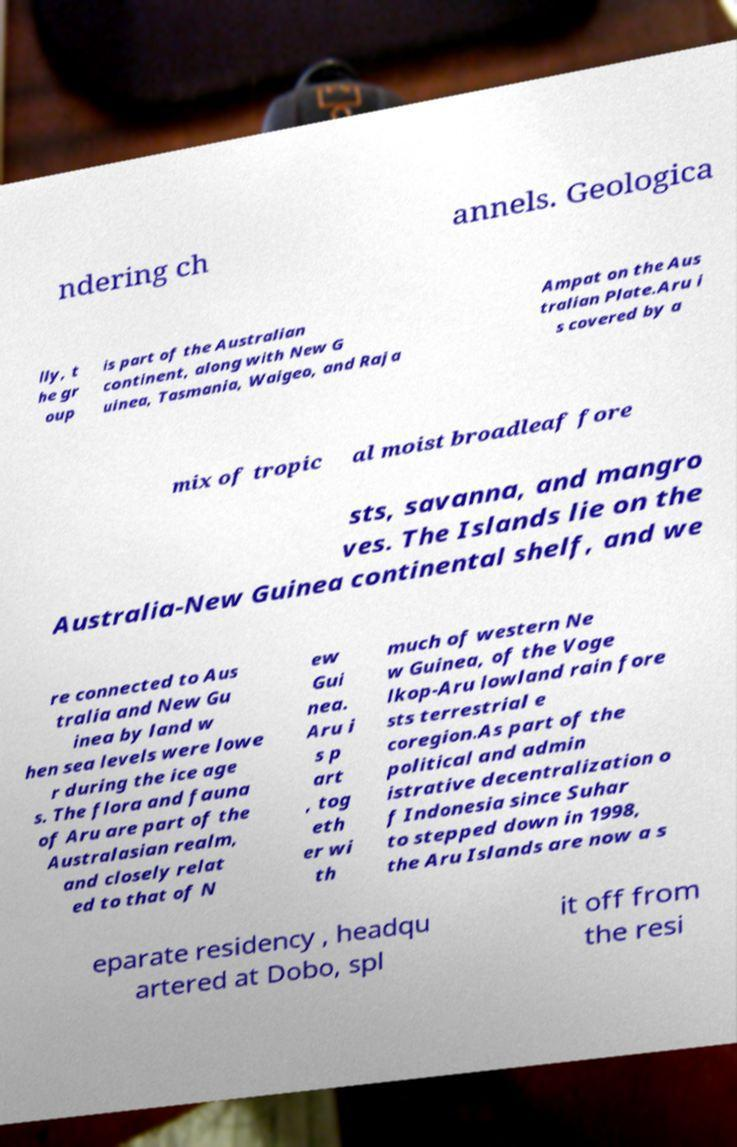I need the written content from this picture converted into text. Can you do that? ndering ch annels. Geologica lly, t he gr oup is part of the Australian continent, along with New G uinea, Tasmania, Waigeo, and Raja Ampat on the Aus tralian Plate.Aru i s covered by a mix of tropic al moist broadleaf fore sts, savanna, and mangro ves. The Islands lie on the Australia-New Guinea continental shelf, and we re connected to Aus tralia and New Gu inea by land w hen sea levels were lowe r during the ice age s. The flora and fauna of Aru are part of the Australasian realm, and closely relat ed to that of N ew Gui nea. Aru i s p art , tog eth er wi th much of western Ne w Guinea, of the Voge lkop-Aru lowland rain fore sts terrestrial e coregion.As part of the political and admin istrative decentralization o f Indonesia since Suhar to stepped down in 1998, the Aru Islands are now a s eparate residency , headqu artered at Dobo, spl it off from the resi 